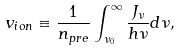Convert formula to latex. <formula><loc_0><loc_0><loc_500><loc_500>v _ { i o n } \equiv \frac { 1 } { n _ { p r e } } \int ^ { \infty } _ { \nu _ { 0 } } \frac { J _ { \nu } } { h \nu } d \nu ,</formula> 